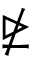Convert formula to latex. <formula><loc_0><loc_0><loc_500><loc_500>\ntrianglerighteq</formula> 